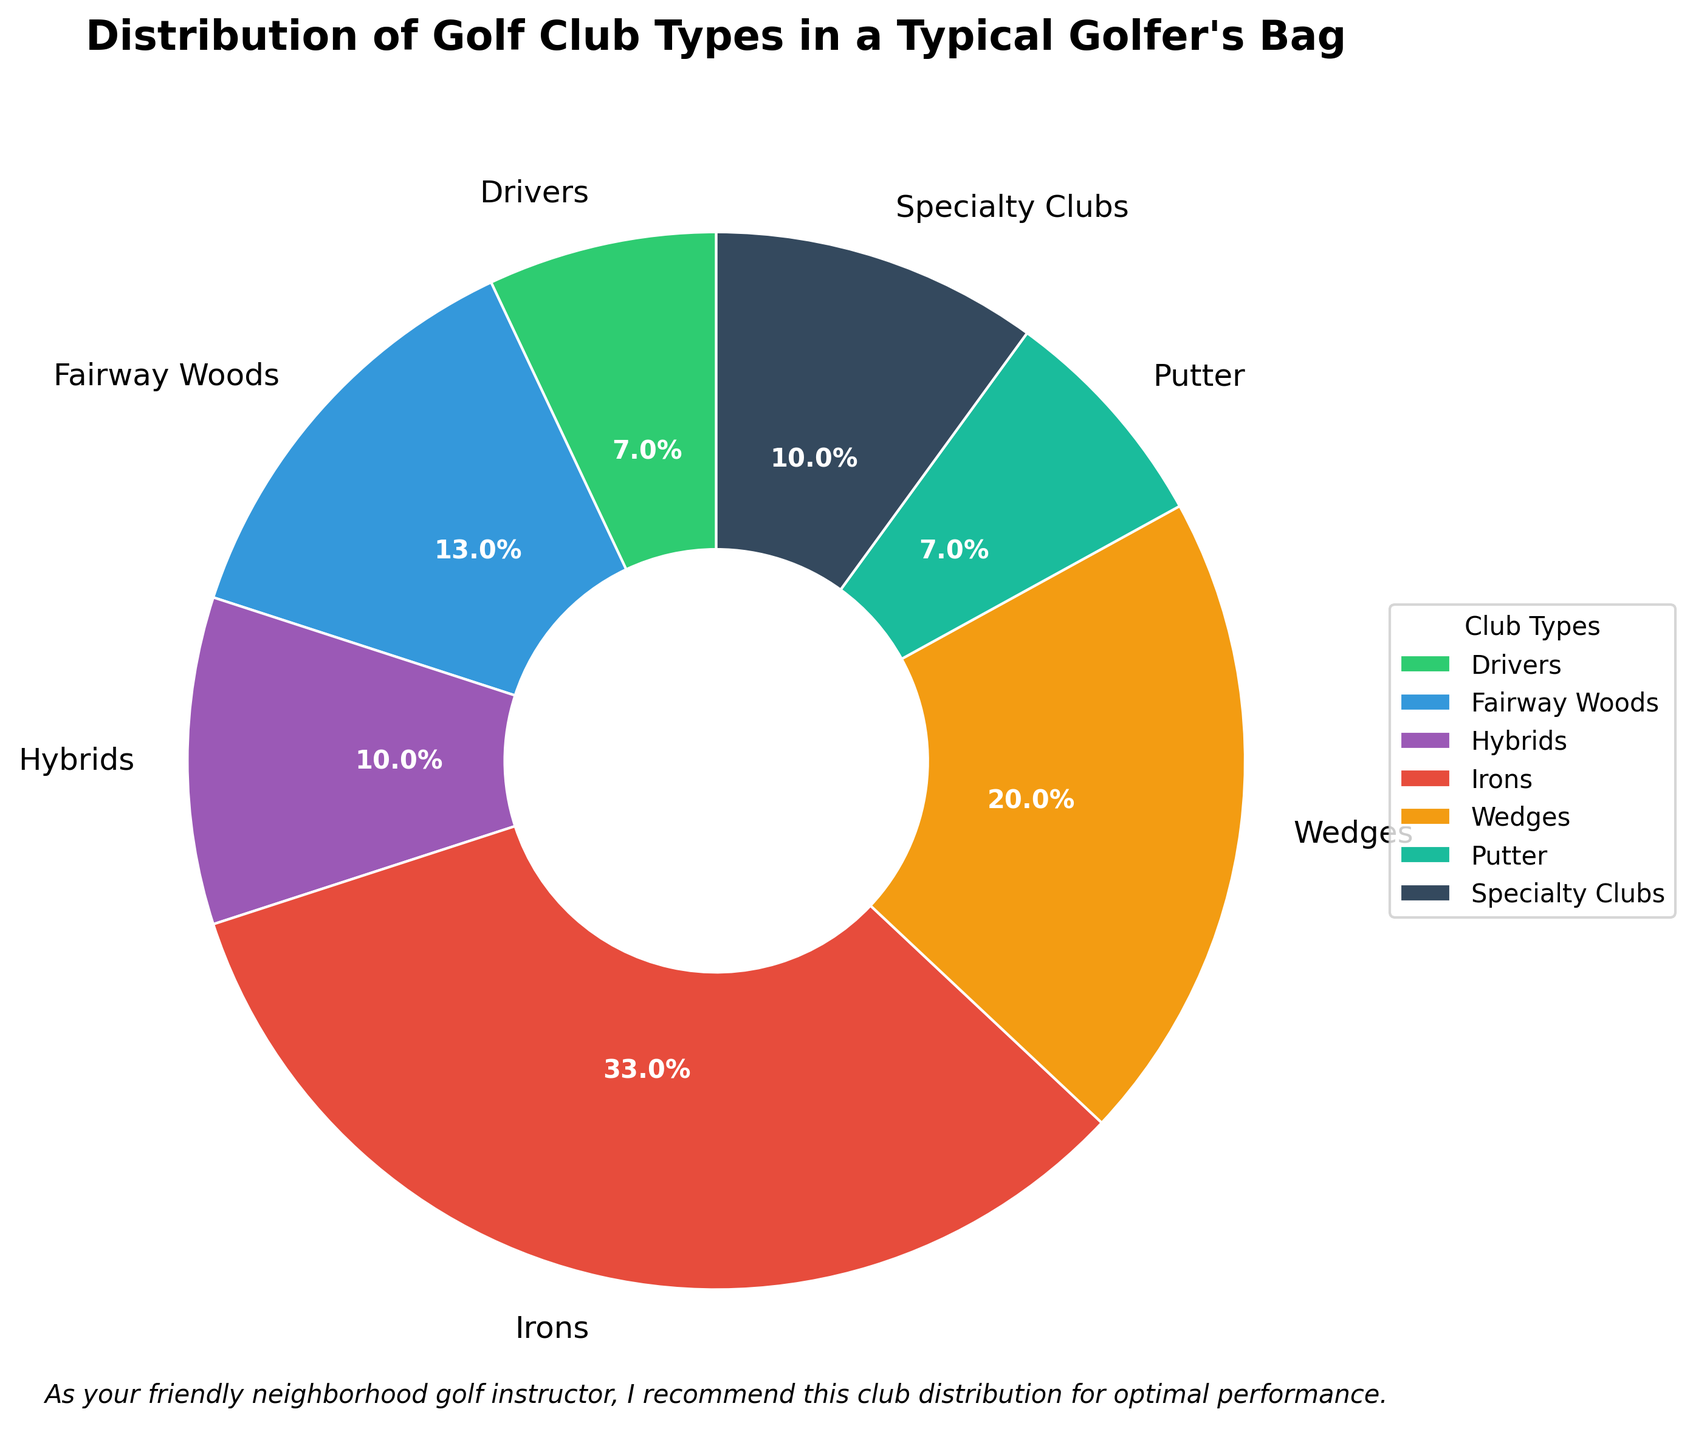Which club type has the largest percentage in a typical golfer's bag? From the chart, the segment representing "Irons" covers the largest area. It's indicated both by the segment's size and the bold "33.0%" label that marks it.
Answer: Irons What is the combined percentage of Hybrids and Specialty Clubs? To find the combined percentage, add the percentages for Hybrids (10%) and Specialty Clubs (10%). 10% + 10% = 20%.
Answer: 20% Which club type has the same percentage as Drivers? From the chart, both Drivers and Putters have a segment labeled "7.0%".
Answer: Putters What is the difference in percentage between the highest and lowest club types? The highest percentage is for Irons (33%) and the lowest is for Drivers or Putters (7%). Subtract the lowest from the highest: 33% - 7% = 26%.
Answer: 26% Are Fairway Woods or Wedges more prevalent in a golfer’s bag, and by how much? Comparing the percentages, Fairway Woods have 13% and Wedges have 20%. Wedges are more prevalent by 20% - 13% = 7%.
Answer: Wedges are more prevalent by 7% What percentage of the bag is comprised of clubs that are neither irons nor wedges? Irons and Wedges together make up 33% + 20% = 53%. The remaining percentage is 100% - 53% = 47%.
Answer: 47% Which club type is represented by a green segment in the chart? The green segment in the pie chart corresponds to Drivers.
Answer: Drivers Which club type, indicated by a purple segment, has a 10% share? The purple segment represents Hybrids, which have a 10% share.
Answer: Hybrids What is the average percentage of the clubs categorized as Hybrids and Specialty Clubs? Adding the percentages for Hybrids (10%) and Specialty Clubs (10%) gives 20%. The average of these two values is 20% / 2 = 10%.
Answer: 10% 